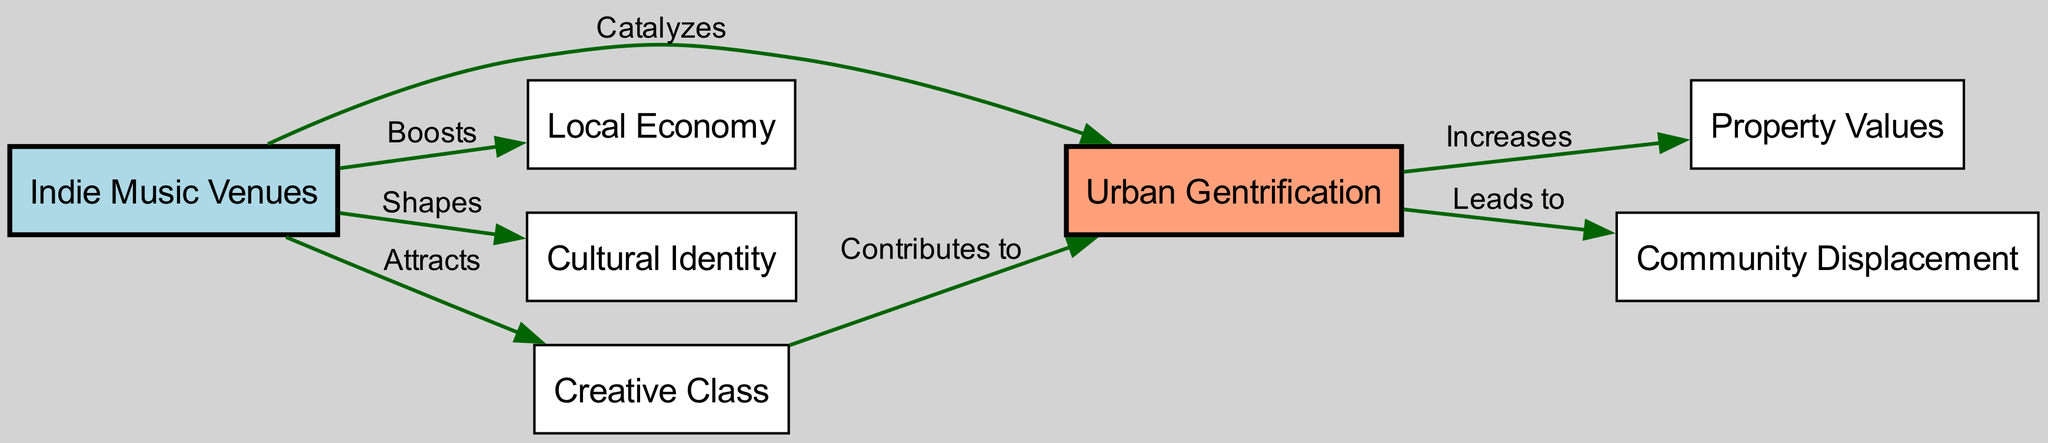What is the primary focus of the concept map? The concept map centers around the relationship between indie music venues and urban gentrification, illustrating how various elements contribute to this dynamic.
Answer: Indie music venues and urban gentrification How many nodes are present in the diagram? By counting all distinct entities shown in the concept map, there are seven nodes representing different concepts related to indie music and urban gentrification.
Answer: 7 Which node is directly connected to "community displacement"? The concept of "community displacement" is directly connected to "urban gentrification," indicating that urban gentrification leads to this phenomenon.
Answer: Urban gentrification What does the indie music venues do to the local economy? The relationship indicates that indie music venues boost the local economy, suggesting they play a role in enhancing economic activity in their areas.
Answer: Boosts Which node contributes to urban gentrification? The "creative class" node contributes to urban gentrification as indicated by the directed edge from "creative class" to "urban gentrification".
Answer: Creative class What kind of impact do indie music venues have on cultural identity? The impact of indie music venues on cultural identity is that they shape it, meaning they influence how culture is expressed in a community.
Answer: Shapes What does urban gentrification do to property values? The relationship shows that urban gentrification increases property values, suggesting that as neighborhoods gentrify, real estate becomes more expensive.
Answer: Increases Which node is attracted by indie music venues? The "creative class" is attracted by indie music venues, indicating that these venues play a significant role in drawing creative individuals to an area.
Answer: Creative class In total, how many edges are present in the concept map? By reviewing the links between nodes, there are six edges, representing the relationships among the nodes within the concept map.
Answer: 6 